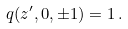Convert formula to latex. <formula><loc_0><loc_0><loc_500><loc_500>q ( z ^ { \prime } , 0 , \pm 1 ) = 1 \, .</formula> 